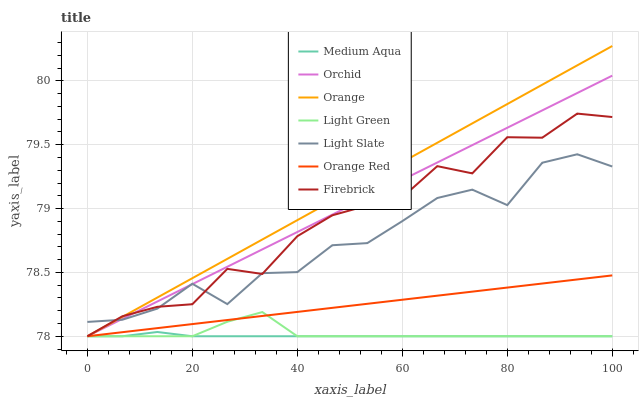Does Medium Aqua have the minimum area under the curve?
Answer yes or no. Yes. Does Orange have the maximum area under the curve?
Answer yes or no. Yes. Does Firebrick have the minimum area under the curve?
Answer yes or no. No. Does Firebrick have the maximum area under the curve?
Answer yes or no. No. Is Orange Red the smoothest?
Answer yes or no. Yes. Is Light Slate the roughest?
Answer yes or no. Yes. Is Firebrick the smoothest?
Answer yes or no. No. Is Firebrick the roughest?
Answer yes or no. No. Does Orange have the highest value?
Answer yes or no. Yes. Does Firebrick have the highest value?
Answer yes or no. No. Is Light Green less than Light Slate?
Answer yes or no. Yes. Is Light Slate greater than Orange Red?
Answer yes or no. Yes. Does Orange intersect Orchid?
Answer yes or no. Yes. Is Orange less than Orchid?
Answer yes or no. No. Is Orange greater than Orchid?
Answer yes or no. No. Does Light Green intersect Light Slate?
Answer yes or no. No. 